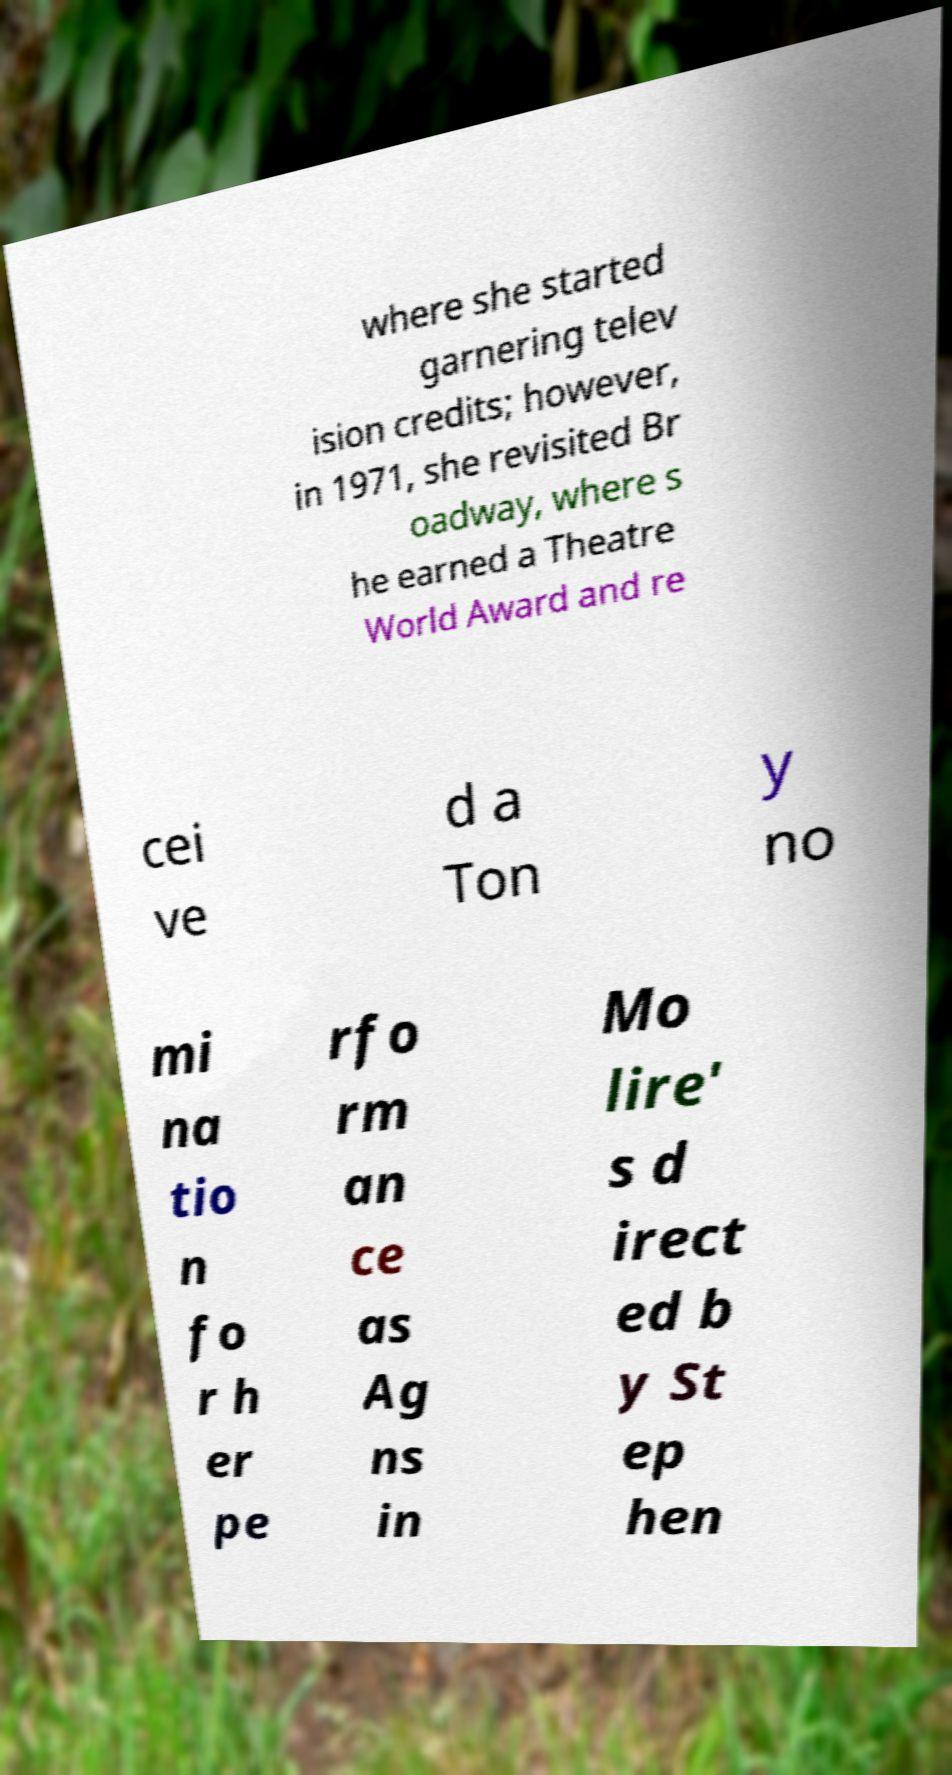Please identify and transcribe the text found in this image. where she started garnering telev ision credits; however, in 1971, she revisited Br oadway, where s he earned a Theatre World Award and re cei ve d a Ton y no mi na tio n fo r h er pe rfo rm an ce as Ag ns in Mo lire' s d irect ed b y St ep hen 